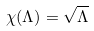Convert formula to latex. <formula><loc_0><loc_0><loc_500><loc_500>\chi ( \Lambda ) = \sqrt { \Lambda }</formula> 